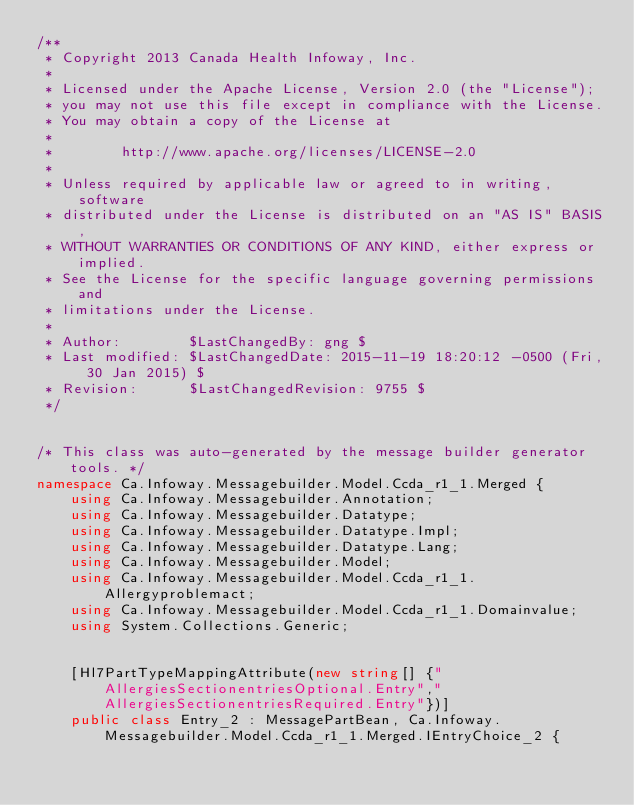<code> <loc_0><loc_0><loc_500><loc_500><_C#_>/**
 * Copyright 2013 Canada Health Infoway, Inc.
 *
 * Licensed under the Apache License, Version 2.0 (the "License");
 * you may not use this file except in compliance with the License.
 * You may obtain a copy of the License at
 *
 *        http://www.apache.org/licenses/LICENSE-2.0
 *
 * Unless required by applicable law or agreed to in writing, software
 * distributed under the License is distributed on an "AS IS" BASIS,
 * WITHOUT WARRANTIES OR CONDITIONS OF ANY KIND, either express or implied.
 * See the License for the specific language governing permissions and
 * limitations under the License.
 *
 * Author:        $LastChangedBy: gng $
 * Last modified: $LastChangedDate: 2015-11-19 18:20:12 -0500 (Fri, 30 Jan 2015) $
 * Revision:      $LastChangedRevision: 9755 $
 */


/* This class was auto-generated by the message builder generator tools. */
namespace Ca.Infoway.Messagebuilder.Model.Ccda_r1_1.Merged {
    using Ca.Infoway.Messagebuilder.Annotation;
    using Ca.Infoway.Messagebuilder.Datatype;
    using Ca.Infoway.Messagebuilder.Datatype.Impl;
    using Ca.Infoway.Messagebuilder.Datatype.Lang;
    using Ca.Infoway.Messagebuilder.Model;
    using Ca.Infoway.Messagebuilder.Model.Ccda_r1_1.Allergyproblemact;
    using Ca.Infoway.Messagebuilder.Model.Ccda_r1_1.Domainvalue;
    using System.Collections.Generic;


    [Hl7PartTypeMappingAttribute(new string[] {"AllergiesSectionentriesOptional.Entry","AllergiesSectionentriesRequired.Entry"})]
    public class Entry_2 : MessagePartBean, Ca.Infoway.Messagebuilder.Model.Ccda_r1_1.Merged.IEntryChoice_2 {
</code> 